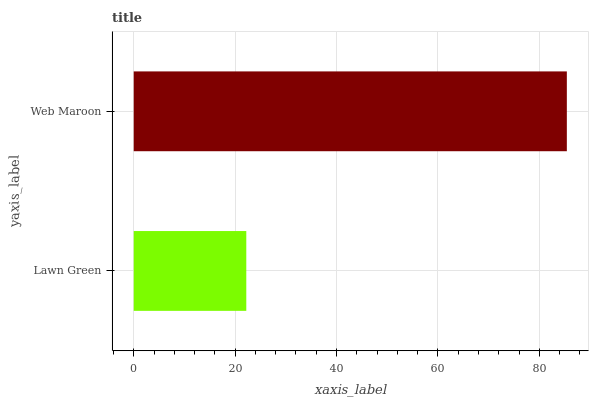Is Lawn Green the minimum?
Answer yes or no. Yes. Is Web Maroon the maximum?
Answer yes or no. Yes. Is Web Maroon the minimum?
Answer yes or no. No. Is Web Maroon greater than Lawn Green?
Answer yes or no. Yes. Is Lawn Green less than Web Maroon?
Answer yes or no. Yes. Is Lawn Green greater than Web Maroon?
Answer yes or no. No. Is Web Maroon less than Lawn Green?
Answer yes or no. No. Is Web Maroon the high median?
Answer yes or no. Yes. Is Lawn Green the low median?
Answer yes or no. Yes. Is Lawn Green the high median?
Answer yes or no. No. Is Web Maroon the low median?
Answer yes or no. No. 